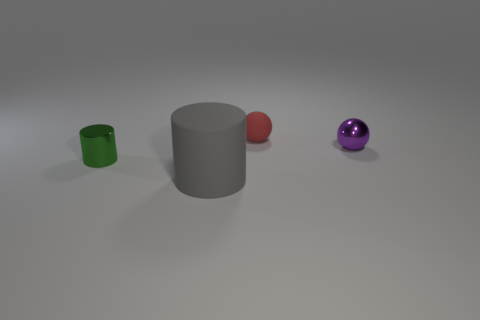Is there any other thing that is the same size as the rubber cylinder?
Make the answer very short. No. The red thing has what shape?
Keep it short and to the point. Sphere. Are the thing left of the gray rubber cylinder and the ball that is in front of the red rubber ball made of the same material?
Provide a succinct answer. Yes. What shape is the red matte thing that is right of the large matte object?
Offer a very short reply. Sphere. There is a purple metal object that is the same shape as the tiny red thing; what is its size?
Offer a very short reply. Small. Is there a purple metal sphere right of the tiny red matte ball right of the green metal thing?
Your answer should be compact. Yes. What color is the big matte thing that is the same shape as the small green thing?
Ensure brevity in your answer.  Gray. There is a small metal object to the right of the cylinder that is in front of the tiny metallic object in front of the purple metal sphere; what is its color?
Make the answer very short. Purple. Is the small red thing made of the same material as the green thing?
Your answer should be very brief. No. Is the small purple metal thing the same shape as the green thing?
Provide a short and direct response. No. 